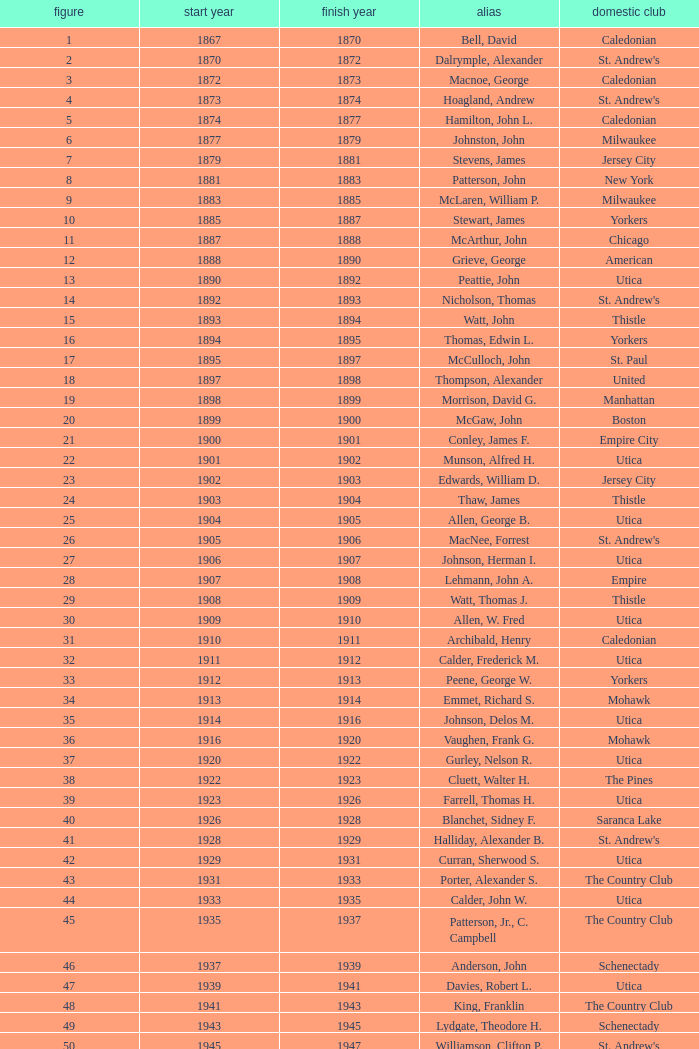Which Number has a Year Start smaller than 1874, and a Year End larger than 1873? 4.0. 